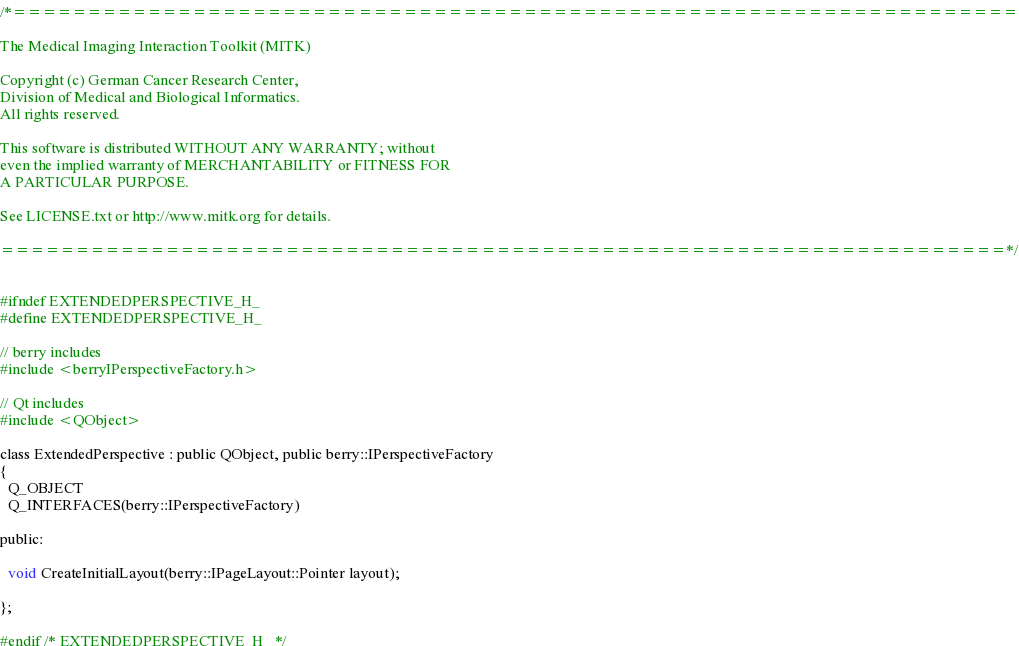Convert code to text. <code><loc_0><loc_0><loc_500><loc_500><_C_>/*===================================================================

The Medical Imaging Interaction Toolkit (MITK)

Copyright (c) German Cancer Research Center,
Division of Medical and Biological Informatics.
All rights reserved.

This software is distributed WITHOUT ANY WARRANTY; without
even the implied warranty of MERCHANTABILITY or FITNESS FOR
A PARTICULAR PURPOSE.

See LICENSE.txt or http://www.mitk.org for details.

===================================================================*/


#ifndef EXTENDEDPERSPECTIVE_H_
#define EXTENDEDPERSPECTIVE_H_

// berry includes
#include <berryIPerspectiveFactory.h>

// Qt includes
#include <QObject>

class ExtendedPerspective : public QObject, public berry::IPerspectiveFactory
{
  Q_OBJECT
  Q_INTERFACES(berry::IPerspectiveFactory)

public:

  void CreateInitialLayout(berry::IPageLayout::Pointer layout);

};

#endif /* EXTENDEDPERSPECTIVE_H_ */
</code> 